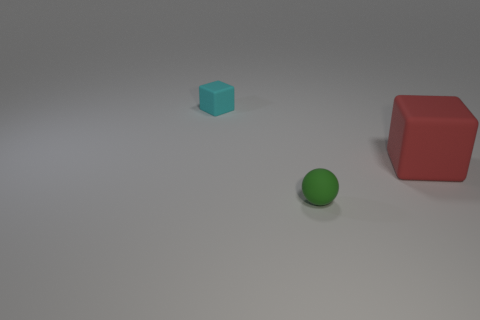Add 2 small rubber blocks. How many objects exist? 5 Subtract all balls. How many objects are left? 2 Subtract all red cubes. How many cubes are left? 1 Subtract 1 balls. How many balls are left? 0 Add 3 tiny purple matte cylinders. How many tiny purple matte cylinders exist? 3 Subtract 0 blue cylinders. How many objects are left? 3 Subtract all cyan blocks. Subtract all blue cylinders. How many blocks are left? 1 Subtract all cyan matte blocks. Subtract all red rubber blocks. How many objects are left? 1 Add 3 small green balls. How many small green balls are left? 4 